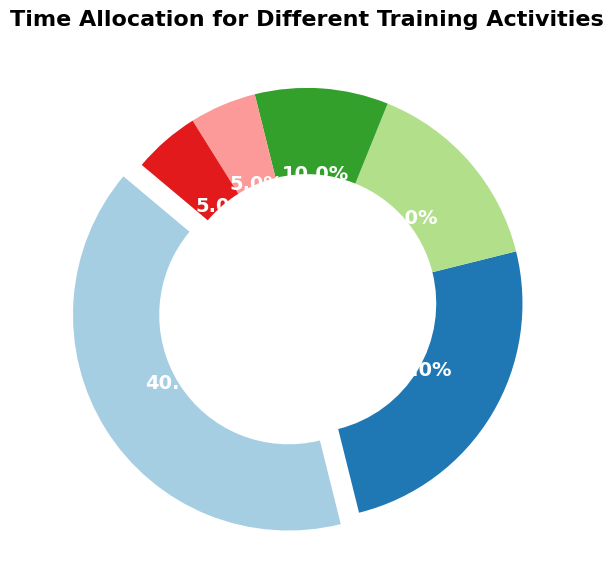How much more time is allocated to Skating compared to Shooting? Skating is 40%, and Shooting is 25%. To find the difference, subtract Shooting's percentage from Skating's percentage: 40% - 25% = 15%.
Answer: 15% Which training activity has the smallest time allocation? By looking at the percentages, both Conditioning and Rest have the smallest allocation of 5%.
Answer: Conditioning and Rest Is more time spent on Strength Training or on Strategy? Compare the percentages of Strength Training (10%) and Strategy (15%). Since 15% is greater than 10%, more time is spent on Strategy.
Answer: Strategy How much total time is allocated to activities other than Skating? Add up the percentages for Shooting (25%), Strategy (15%), Strength Training (10%), Conditioning (5%), and Rest (5%): 25% + 15% + 10% + 5% + 5% = 60%.
Answer: 60% Which two activities together occupy exactly half of the training time? 40% for Skating and 10% for Strength Training sum up to 50%.
Answer: Skating and Strength Training Are Skating and Shooting combined allocated more time than all other activities combined? Combined percentage of Skating and Shooting: 40% + 25% = 65%. Combined percentage of other activities: 15% (Strategy) + 10% (Strength Training) + 5% (Conditioning) + 5% (Rest) = 35%. Since 65% is more than 35%, Skating and Shooting combined are allocated more time.
Answer: Yes How much more time is spent on Skating than on Conditioning and Rest together? Sum the percentages for Conditioning (5%) and Rest (5%): 5% + 5% = 10%. Next, subtract this sum from the percentage for Skating: 40% - 10% = 30%.
Answer: 30% Which activity has the highest time allocation, and how is it visually represented on the chart? Skating has the highest time allocation at 40%, represented by the largest sector of the pie chart that is also slightly "exploded" for emphasis.
Answer: Skating with an exploded slice What is the combined percentage for Strength Training, Conditioning, and Rest? Add the percentages: Strength Training (10%) + Conditioning (5%) + Rest (5%) = 10% + 5% + 5% = 20%.
Answer: 20% What percentage of time is allocated to Strategy and Shooting combined, and how does this compare to Skating? Add Strategy (15%) and Shooting (25%): 15% + 25% = 40%. Comparing this to Skating which is also 40%, they are equal.
Answer: 40% 